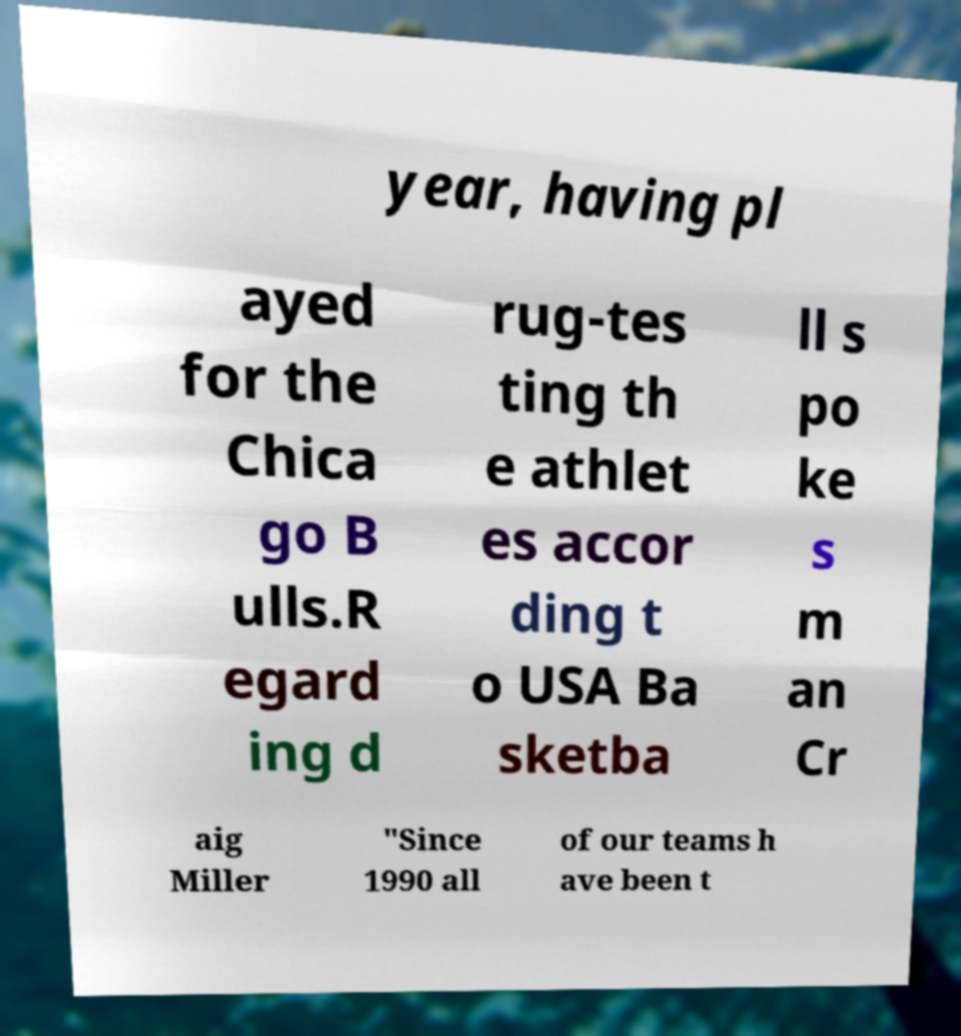I need the written content from this picture converted into text. Can you do that? year, having pl ayed for the Chica go B ulls.R egard ing d rug-tes ting th e athlet es accor ding t o USA Ba sketba ll s po ke s m an Cr aig Miller "Since 1990 all of our teams h ave been t 